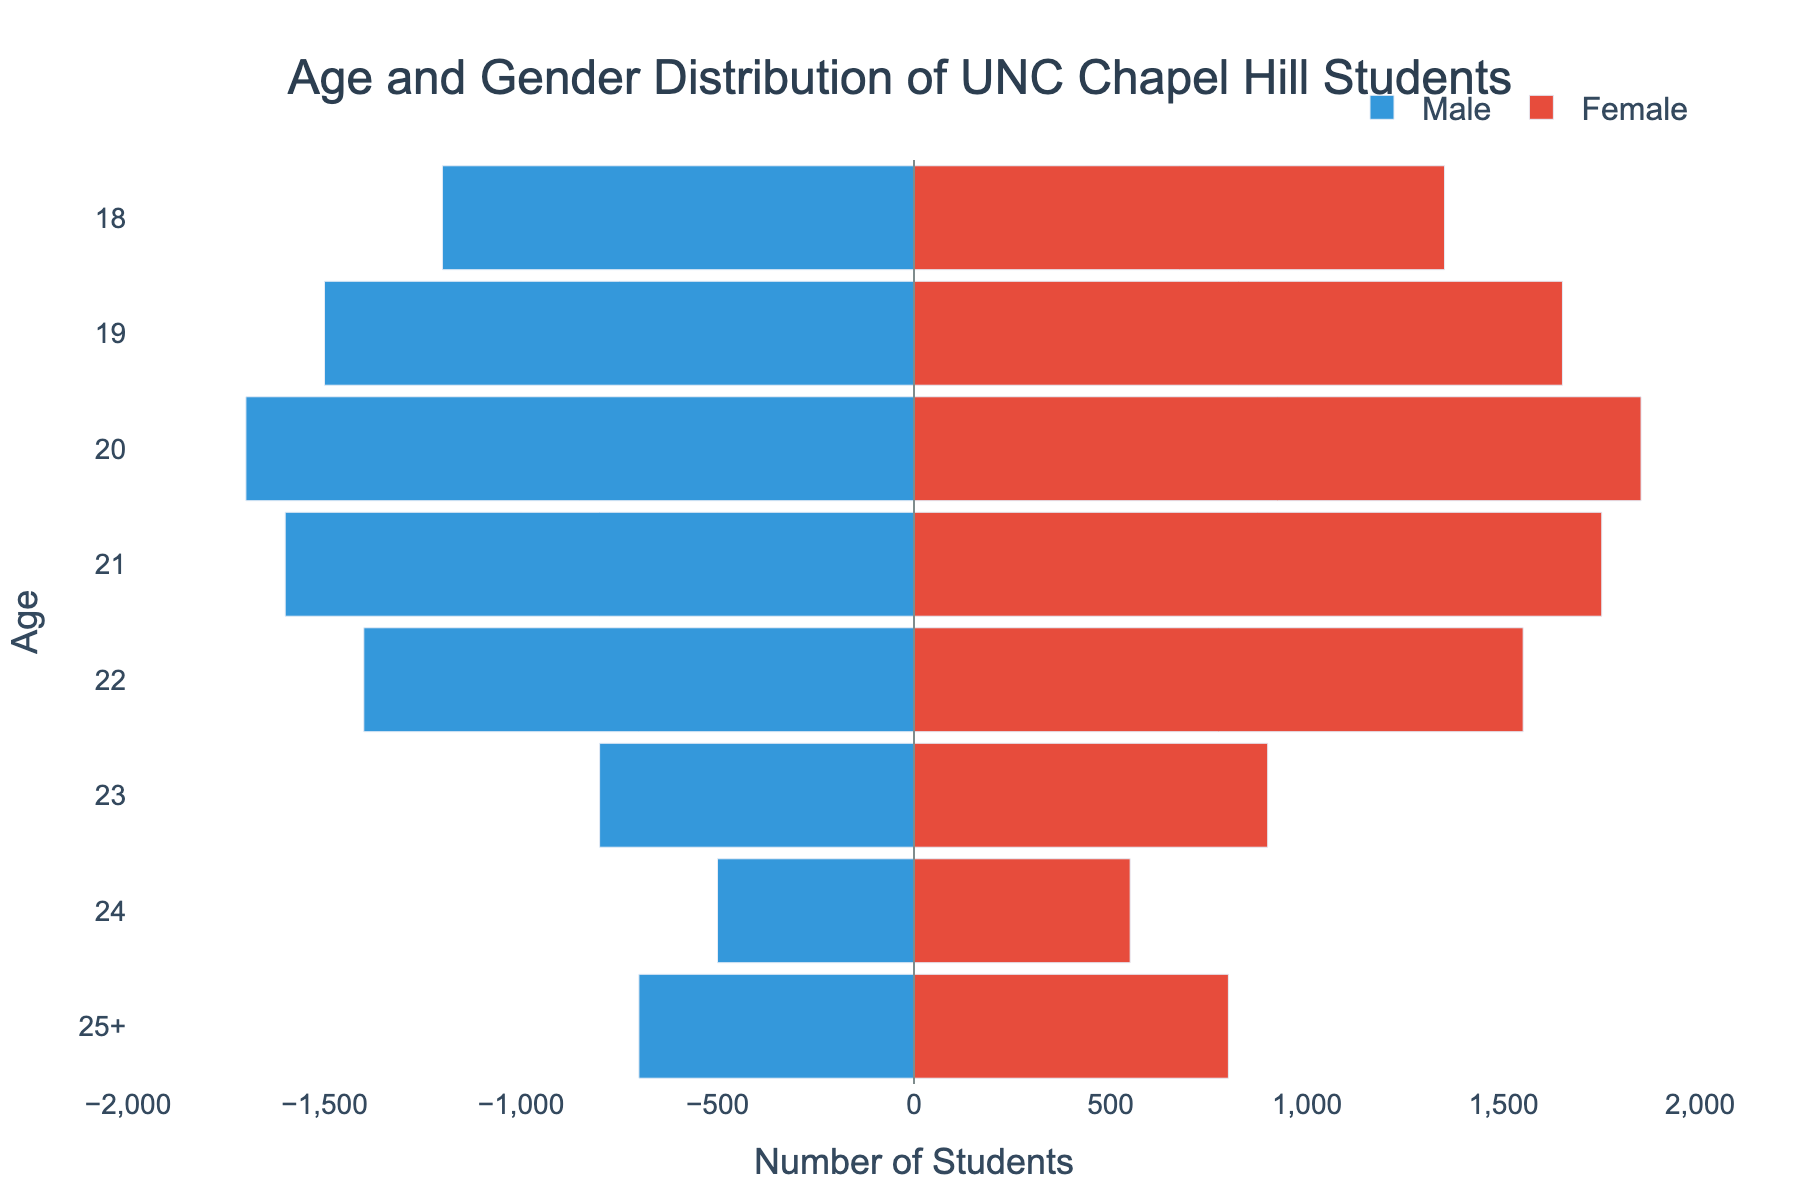What is the title of the plot? The title of the plot is located at the top and is typically written in a larger font for emphasis. The title provides an overview of what the plot represents.
Answer: Age and Gender Distribution of UNC Chapel Hill Students What is the age group with the highest number of female students? To find the age group with the highest number of female students, locate the longest red bar on the right side of the plot.
Answer: 20 How many male students are there aged 22? Look at the bar representing males aged 22 and note the negative value since male values are displayed on the left side.
Answer: 1400 Compare the number of male students aged 18 to those aged 19. Which age has more male students and by how much? Identify the lengths of the bars representing males aged 18 and 19. Calculate the difference by subtracting the two values.
Answer: Age 19, 300 more male students What is the total number of students aged 23? Add the number of male students and female students aged 23.
Answer: 1700 Which gender has a larger number of students aged 21, and how many more? Compare the lengths of the bars for males and females aged 21. Subtract the smaller value from the larger value to find the difference.
Answer: Female, 150 more What age group has the smallest difference between the number of male and female students, and what is that difference? Calculate the absolute difference between male and female students for each age group, then identify the group with the smallest difference.
Answer: 23, 100 difference Is the total number of male or female students larger, and by how many? Sum the bars for each gender and compare the totals. Subtract the smaller sum from the larger to find the difference.
Answer: Female, 700 more What age category shows an increase in students when moving from age 22 to 23 for males? Compare the bar lengths for males aged 22 and 23. Look at whether the bar for age 23 is longer than for age 22.
Answer: None (there is a decrease) What is the average number of students (male and female combined) aged 25 and above? Add the number of male and female students in the 25+ category and divide by 2.
Answer: 750 